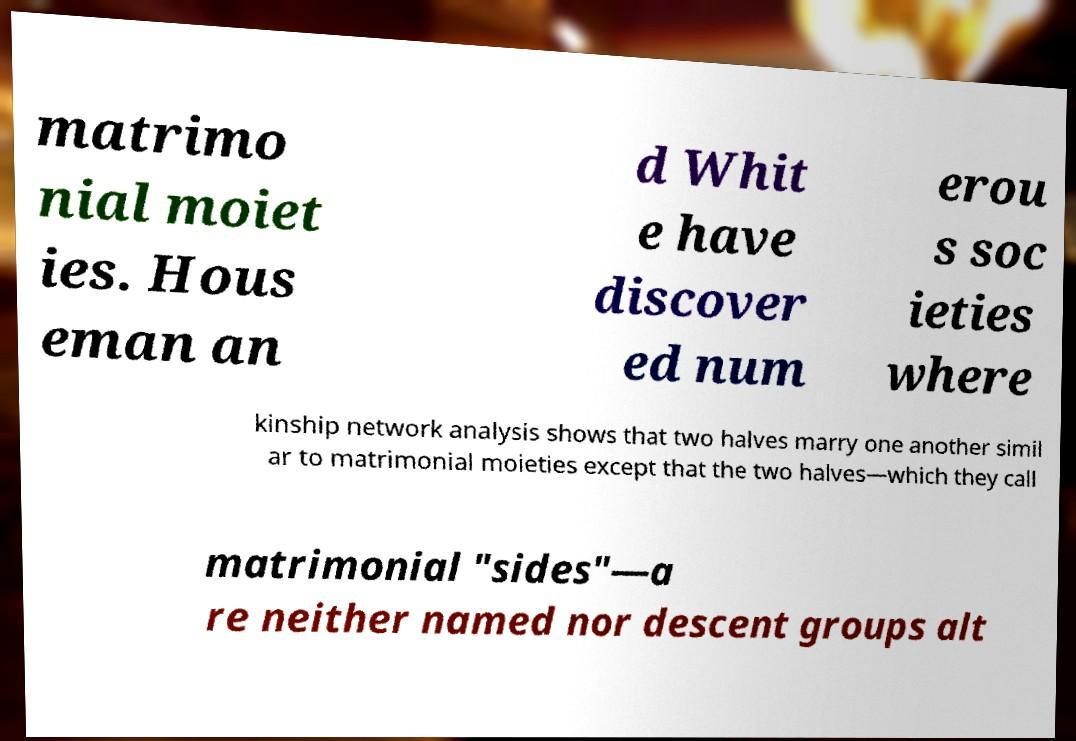Please identify and transcribe the text found in this image. matrimo nial moiet ies. Hous eman an d Whit e have discover ed num erou s soc ieties where kinship network analysis shows that two halves marry one another simil ar to matrimonial moieties except that the two halves—which they call matrimonial "sides"—a re neither named nor descent groups alt 